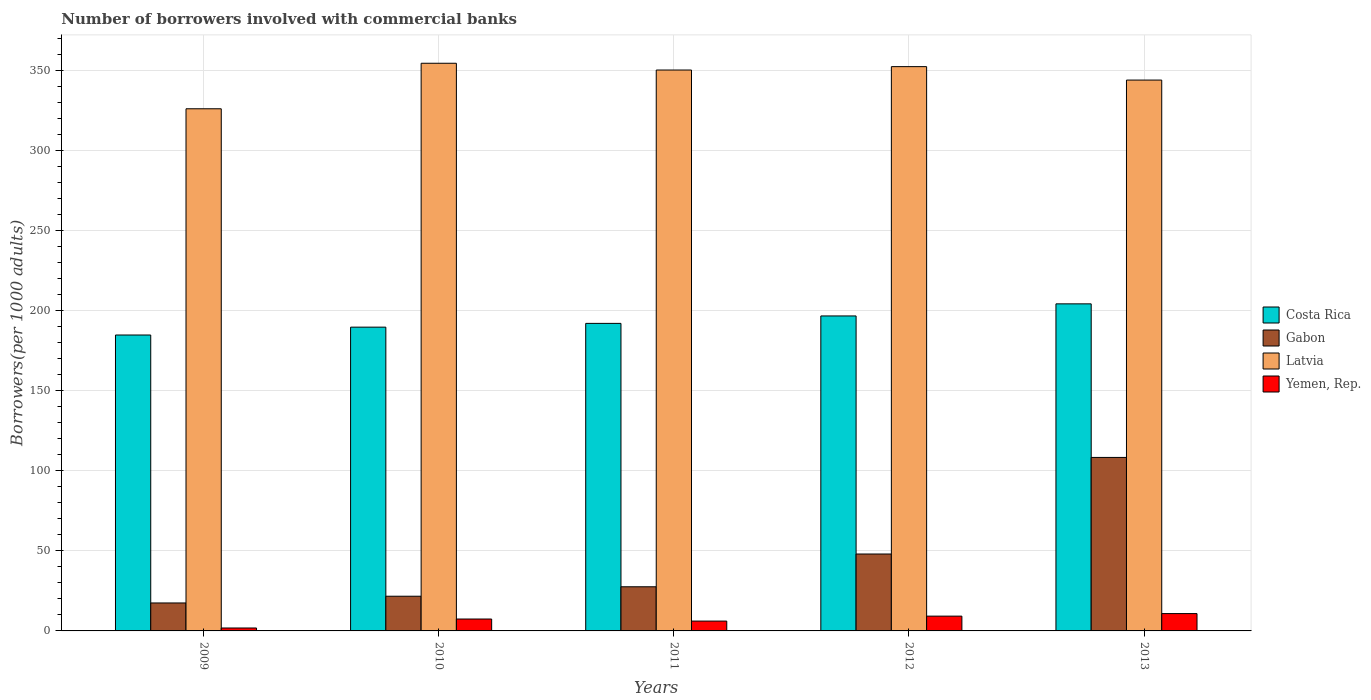How many different coloured bars are there?
Your answer should be very brief. 4. Are the number of bars per tick equal to the number of legend labels?
Your answer should be very brief. Yes. Are the number of bars on each tick of the X-axis equal?
Keep it short and to the point. Yes. How many bars are there on the 3rd tick from the left?
Offer a very short reply. 4. How many bars are there on the 2nd tick from the right?
Provide a short and direct response. 4. In how many cases, is the number of bars for a given year not equal to the number of legend labels?
Provide a succinct answer. 0. What is the number of borrowers involved with commercial banks in Yemen, Rep. in 2012?
Your response must be concise. 9.23. Across all years, what is the maximum number of borrowers involved with commercial banks in Gabon?
Offer a terse response. 108.3. Across all years, what is the minimum number of borrowers involved with commercial banks in Yemen, Rep.?
Your answer should be compact. 1.83. What is the total number of borrowers involved with commercial banks in Gabon in the graph?
Give a very brief answer. 222.99. What is the difference between the number of borrowers involved with commercial banks in Costa Rica in 2009 and that in 2012?
Your answer should be very brief. -11.9. What is the difference between the number of borrowers involved with commercial banks in Costa Rica in 2010 and the number of borrowers involved with commercial banks in Yemen, Rep. in 2009?
Make the answer very short. 187.8. What is the average number of borrowers involved with commercial banks in Gabon per year?
Offer a very short reply. 44.6. In the year 2010, what is the difference between the number of borrowers involved with commercial banks in Yemen, Rep. and number of borrowers involved with commercial banks in Gabon?
Keep it short and to the point. -14.22. In how many years, is the number of borrowers involved with commercial banks in Latvia greater than 90?
Offer a terse response. 5. What is the ratio of the number of borrowers involved with commercial banks in Gabon in 2010 to that in 2011?
Ensure brevity in your answer.  0.79. Is the number of borrowers involved with commercial banks in Yemen, Rep. in 2011 less than that in 2013?
Your response must be concise. Yes. Is the difference between the number of borrowers involved with commercial banks in Yemen, Rep. in 2011 and 2012 greater than the difference between the number of borrowers involved with commercial banks in Gabon in 2011 and 2012?
Your answer should be very brief. Yes. What is the difference between the highest and the second highest number of borrowers involved with commercial banks in Yemen, Rep.?
Ensure brevity in your answer.  1.58. What is the difference between the highest and the lowest number of borrowers involved with commercial banks in Yemen, Rep.?
Keep it short and to the point. 8.99. In how many years, is the number of borrowers involved with commercial banks in Yemen, Rep. greater than the average number of borrowers involved with commercial banks in Yemen, Rep. taken over all years?
Provide a short and direct response. 3. What does the 3rd bar from the left in 2012 represents?
Your response must be concise. Latvia. Is it the case that in every year, the sum of the number of borrowers involved with commercial banks in Latvia and number of borrowers involved with commercial banks in Yemen, Rep. is greater than the number of borrowers involved with commercial banks in Gabon?
Offer a very short reply. Yes. How many bars are there?
Provide a succinct answer. 20. What is the difference between two consecutive major ticks on the Y-axis?
Provide a succinct answer. 50. Are the values on the major ticks of Y-axis written in scientific E-notation?
Offer a terse response. No. How many legend labels are there?
Your answer should be very brief. 4. How are the legend labels stacked?
Keep it short and to the point. Vertical. What is the title of the graph?
Provide a short and direct response. Number of borrowers involved with commercial banks. Does "Equatorial Guinea" appear as one of the legend labels in the graph?
Your answer should be very brief. No. What is the label or title of the Y-axis?
Keep it short and to the point. Borrowers(per 1000 adults). What is the Borrowers(per 1000 adults) in Costa Rica in 2009?
Keep it short and to the point. 184.73. What is the Borrowers(per 1000 adults) in Gabon in 2009?
Offer a terse response. 17.46. What is the Borrowers(per 1000 adults) in Latvia in 2009?
Give a very brief answer. 325.95. What is the Borrowers(per 1000 adults) of Yemen, Rep. in 2009?
Provide a short and direct response. 1.83. What is the Borrowers(per 1000 adults) of Costa Rica in 2010?
Keep it short and to the point. 189.63. What is the Borrowers(per 1000 adults) of Gabon in 2010?
Make the answer very short. 21.66. What is the Borrowers(per 1000 adults) of Latvia in 2010?
Ensure brevity in your answer.  354.36. What is the Borrowers(per 1000 adults) of Yemen, Rep. in 2010?
Offer a terse response. 7.43. What is the Borrowers(per 1000 adults) in Costa Rica in 2011?
Your answer should be very brief. 191.98. What is the Borrowers(per 1000 adults) in Gabon in 2011?
Provide a short and direct response. 27.56. What is the Borrowers(per 1000 adults) of Latvia in 2011?
Offer a terse response. 350.14. What is the Borrowers(per 1000 adults) in Yemen, Rep. in 2011?
Your answer should be compact. 6.14. What is the Borrowers(per 1000 adults) of Costa Rica in 2012?
Give a very brief answer. 196.62. What is the Borrowers(per 1000 adults) of Gabon in 2012?
Your answer should be compact. 48.02. What is the Borrowers(per 1000 adults) in Latvia in 2012?
Provide a succinct answer. 352.26. What is the Borrowers(per 1000 adults) in Yemen, Rep. in 2012?
Provide a succinct answer. 9.23. What is the Borrowers(per 1000 adults) of Costa Rica in 2013?
Ensure brevity in your answer.  204.18. What is the Borrowers(per 1000 adults) in Gabon in 2013?
Your answer should be very brief. 108.3. What is the Borrowers(per 1000 adults) in Latvia in 2013?
Give a very brief answer. 343.87. What is the Borrowers(per 1000 adults) of Yemen, Rep. in 2013?
Provide a succinct answer. 10.82. Across all years, what is the maximum Borrowers(per 1000 adults) of Costa Rica?
Offer a terse response. 204.18. Across all years, what is the maximum Borrowers(per 1000 adults) in Gabon?
Your answer should be compact. 108.3. Across all years, what is the maximum Borrowers(per 1000 adults) of Latvia?
Your response must be concise. 354.36. Across all years, what is the maximum Borrowers(per 1000 adults) of Yemen, Rep.?
Provide a short and direct response. 10.82. Across all years, what is the minimum Borrowers(per 1000 adults) in Costa Rica?
Give a very brief answer. 184.73. Across all years, what is the minimum Borrowers(per 1000 adults) in Gabon?
Make the answer very short. 17.46. Across all years, what is the minimum Borrowers(per 1000 adults) in Latvia?
Keep it short and to the point. 325.95. Across all years, what is the minimum Borrowers(per 1000 adults) in Yemen, Rep.?
Provide a succinct answer. 1.83. What is the total Borrowers(per 1000 adults) in Costa Rica in the graph?
Offer a terse response. 967.14. What is the total Borrowers(per 1000 adults) in Gabon in the graph?
Offer a terse response. 222.99. What is the total Borrowers(per 1000 adults) of Latvia in the graph?
Your response must be concise. 1726.58. What is the total Borrowers(per 1000 adults) of Yemen, Rep. in the graph?
Offer a very short reply. 35.45. What is the difference between the Borrowers(per 1000 adults) in Costa Rica in 2009 and that in 2010?
Give a very brief answer. -4.9. What is the difference between the Borrowers(per 1000 adults) of Gabon in 2009 and that in 2010?
Your answer should be compact. -4.2. What is the difference between the Borrowers(per 1000 adults) of Latvia in 2009 and that in 2010?
Give a very brief answer. -28.41. What is the difference between the Borrowers(per 1000 adults) in Yemen, Rep. in 2009 and that in 2010?
Provide a succinct answer. -5.6. What is the difference between the Borrowers(per 1000 adults) of Costa Rica in 2009 and that in 2011?
Your answer should be very brief. -7.25. What is the difference between the Borrowers(per 1000 adults) of Gabon in 2009 and that in 2011?
Your response must be concise. -10.1. What is the difference between the Borrowers(per 1000 adults) of Latvia in 2009 and that in 2011?
Provide a short and direct response. -24.19. What is the difference between the Borrowers(per 1000 adults) of Yemen, Rep. in 2009 and that in 2011?
Your answer should be very brief. -4.32. What is the difference between the Borrowers(per 1000 adults) of Costa Rica in 2009 and that in 2012?
Ensure brevity in your answer.  -11.9. What is the difference between the Borrowers(per 1000 adults) of Gabon in 2009 and that in 2012?
Provide a short and direct response. -30.56. What is the difference between the Borrowers(per 1000 adults) of Latvia in 2009 and that in 2012?
Offer a terse response. -26.3. What is the difference between the Borrowers(per 1000 adults) of Yemen, Rep. in 2009 and that in 2012?
Give a very brief answer. -7.41. What is the difference between the Borrowers(per 1000 adults) of Costa Rica in 2009 and that in 2013?
Ensure brevity in your answer.  -19.45. What is the difference between the Borrowers(per 1000 adults) of Gabon in 2009 and that in 2013?
Keep it short and to the point. -90.84. What is the difference between the Borrowers(per 1000 adults) of Latvia in 2009 and that in 2013?
Your answer should be compact. -17.92. What is the difference between the Borrowers(per 1000 adults) in Yemen, Rep. in 2009 and that in 2013?
Make the answer very short. -8.99. What is the difference between the Borrowers(per 1000 adults) of Costa Rica in 2010 and that in 2011?
Make the answer very short. -2.35. What is the difference between the Borrowers(per 1000 adults) of Gabon in 2010 and that in 2011?
Make the answer very short. -5.9. What is the difference between the Borrowers(per 1000 adults) of Latvia in 2010 and that in 2011?
Provide a short and direct response. 4.22. What is the difference between the Borrowers(per 1000 adults) of Yemen, Rep. in 2010 and that in 2011?
Offer a terse response. 1.29. What is the difference between the Borrowers(per 1000 adults) of Costa Rica in 2010 and that in 2012?
Your answer should be very brief. -6.99. What is the difference between the Borrowers(per 1000 adults) in Gabon in 2010 and that in 2012?
Provide a short and direct response. -26.36. What is the difference between the Borrowers(per 1000 adults) in Latvia in 2010 and that in 2012?
Offer a terse response. 2.11. What is the difference between the Borrowers(per 1000 adults) of Yemen, Rep. in 2010 and that in 2012?
Your answer should be very brief. -1.8. What is the difference between the Borrowers(per 1000 adults) in Costa Rica in 2010 and that in 2013?
Your response must be concise. -14.55. What is the difference between the Borrowers(per 1000 adults) in Gabon in 2010 and that in 2013?
Ensure brevity in your answer.  -86.65. What is the difference between the Borrowers(per 1000 adults) of Latvia in 2010 and that in 2013?
Keep it short and to the point. 10.49. What is the difference between the Borrowers(per 1000 adults) in Yemen, Rep. in 2010 and that in 2013?
Give a very brief answer. -3.39. What is the difference between the Borrowers(per 1000 adults) in Costa Rica in 2011 and that in 2012?
Provide a succinct answer. -4.64. What is the difference between the Borrowers(per 1000 adults) in Gabon in 2011 and that in 2012?
Ensure brevity in your answer.  -20.46. What is the difference between the Borrowers(per 1000 adults) of Latvia in 2011 and that in 2012?
Ensure brevity in your answer.  -2.12. What is the difference between the Borrowers(per 1000 adults) of Yemen, Rep. in 2011 and that in 2012?
Provide a succinct answer. -3.09. What is the difference between the Borrowers(per 1000 adults) of Costa Rica in 2011 and that in 2013?
Your answer should be compact. -12.19. What is the difference between the Borrowers(per 1000 adults) of Gabon in 2011 and that in 2013?
Your answer should be very brief. -80.74. What is the difference between the Borrowers(per 1000 adults) of Latvia in 2011 and that in 2013?
Offer a terse response. 6.27. What is the difference between the Borrowers(per 1000 adults) in Yemen, Rep. in 2011 and that in 2013?
Provide a succinct answer. -4.67. What is the difference between the Borrowers(per 1000 adults) of Costa Rica in 2012 and that in 2013?
Ensure brevity in your answer.  -7.55. What is the difference between the Borrowers(per 1000 adults) of Gabon in 2012 and that in 2013?
Your response must be concise. -60.28. What is the difference between the Borrowers(per 1000 adults) of Latvia in 2012 and that in 2013?
Give a very brief answer. 8.39. What is the difference between the Borrowers(per 1000 adults) of Yemen, Rep. in 2012 and that in 2013?
Give a very brief answer. -1.58. What is the difference between the Borrowers(per 1000 adults) in Costa Rica in 2009 and the Borrowers(per 1000 adults) in Gabon in 2010?
Offer a very short reply. 163.07. What is the difference between the Borrowers(per 1000 adults) in Costa Rica in 2009 and the Borrowers(per 1000 adults) in Latvia in 2010?
Ensure brevity in your answer.  -169.63. What is the difference between the Borrowers(per 1000 adults) of Costa Rica in 2009 and the Borrowers(per 1000 adults) of Yemen, Rep. in 2010?
Provide a succinct answer. 177.3. What is the difference between the Borrowers(per 1000 adults) of Gabon in 2009 and the Borrowers(per 1000 adults) of Latvia in 2010?
Your response must be concise. -336.91. What is the difference between the Borrowers(per 1000 adults) of Gabon in 2009 and the Borrowers(per 1000 adults) of Yemen, Rep. in 2010?
Your answer should be compact. 10.03. What is the difference between the Borrowers(per 1000 adults) of Latvia in 2009 and the Borrowers(per 1000 adults) of Yemen, Rep. in 2010?
Your response must be concise. 318.52. What is the difference between the Borrowers(per 1000 adults) of Costa Rica in 2009 and the Borrowers(per 1000 adults) of Gabon in 2011?
Provide a succinct answer. 157.17. What is the difference between the Borrowers(per 1000 adults) in Costa Rica in 2009 and the Borrowers(per 1000 adults) in Latvia in 2011?
Your answer should be compact. -165.41. What is the difference between the Borrowers(per 1000 adults) in Costa Rica in 2009 and the Borrowers(per 1000 adults) in Yemen, Rep. in 2011?
Provide a short and direct response. 178.58. What is the difference between the Borrowers(per 1000 adults) of Gabon in 2009 and the Borrowers(per 1000 adults) of Latvia in 2011?
Offer a very short reply. -332.68. What is the difference between the Borrowers(per 1000 adults) of Gabon in 2009 and the Borrowers(per 1000 adults) of Yemen, Rep. in 2011?
Give a very brief answer. 11.31. What is the difference between the Borrowers(per 1000 adults) in Latvia in 2009 and the Borrowers(per 1000 adults) in Yemen, Rep. in 2011?
Give a very brief answer. 319.81. What is the difference between the Borrowers(per 1000 adults) in Costa Rica in 2009 and the Borrowers(per 1000 adults) in Gabon in 2012?
Provide a succinct answer. 136.71. What is the difference between the Borrowers(per 1000 adults) in Costa Rica in 2009 and the Borrowers(per 1000 adults) in Latvia in 2012?
Your answer should be very brief. -167.53. What is the difference between the Borrowers(per 1000 adults) of Costa Rica in 2009 and the Borrowers(per 1000 adults) of Yemen, Rep. in 2012?
Make the answer very short. 175.5. What is the difference between the Borrowers(per 1000 adults) in Gabon in 2009 and the Borrowers(per 1000 adults) in Latvia in 2012?
Your response must be concise. -334.8. What is the difference between the Borrowers(per 1000 adults) of Gabon in 2009 and the Borrowers(per 1000 adults) of Yemen, Rep. in 2012?
Offer a very short reply. 8.22. What is the difference between the Borrowers(per 1000 adults) in Latvia in 2009 and the Borrowers(per 1000 adults) in Yemen, Rep. in 2012?
Provide a short and direct response. 316.72. What is the difference between the Borrowers(per 1000 adults) of Costa Rica in 2009 and the Borrowers(per 1000 adults) of Gabon in 2013?
Your answer should be compact. 76.43. What is the difference between the Borrowers(per 1000 adults) of Costa Rica in 2009 and the Borrowers(per 1000 adults) of Latvia in 2013?
Provide a succinct answer. -159.14. What is the difference between the Borrowers(per 1000 adults) of Costa Rica in 2009 and the Borrowers(per 1000 adults) of Yemen, Rep. in 2013?
Make the answer very short. 173.91. What is the difference between the Borrowers(per 1000 adults) in Gabon in 2009 and the Borrowers(per 1000 adults) in Latvia in 2013?
Provide a short and direct response. -326.41. What is the difference between the Borrowers(per 1000 adults) of Gabon in 2009 and the Borrowers(per 1000 adults) of Yemen, Rep. in 2013?
Give a very brief answer. 6.64. What is the difference between the Borrowers(per 1000 adults) of Latvia in 2009 and the Borrowers(per 1000 adults) of Yemen, Rep. in 2013?
Offer a terse response. 315.13. What is the difference between the Borrowers(per 1000 adults) of Costa Rica in 2010 and the Borrowers(per 1000 adults) of Gabon in 2011?
Offer a terse response. 162.07. What is the difference between the Borrowers(per 1000 adults) in Costa Rica in 2010 and the Borrowers(per 1000 adults) in Latvia in 2011?
Your response must be concise. -160.51. What is the difference between the Borrowers(per 1000 adults) of Costa Rica in 2010 and the Borrowers(per 1000 adults) of Yemen, Rep. in 2011?
Provide a short and direct response. 183.49. What is the difference between the Borrowers(per 1000 adults) in Gabon in 2010 and the Borrowers(per 1000 adults) in Latvia in 2011?
Offer a very short reply. -328.48. What is the difference between the Borrowers(per 1000 adults) of Gabon in 2010 and the Borrowers(per 1000 adults) of Yemen, Rep. in 2011?
Make the answer very short. 15.51. What is the difference between the Borrowers(per 1000 adults) in Latvia in 2010 and the Borrowers(per 1000 adults) in Yemen, Rep. in 2011?
Keep it short and to the point. 348.22. What is the difference between the Borrowers(per 1000 adults) in Costa Rica in 2010 and the Borrowers(per 1000 adults) in Gabon in 2012?
Give a very brief answer. 141.61. What is the difference between the Borrowers(per 1000 adults) of Costa Rica in 2010 and the Borrowers(per 1000 adults) of Latvia in 2012?
Keep it short and to the point. -162.63. What is the difference between the Borrowers(per 1000 adults) in Costa Rica in 2010 and the Borrowers(per 1000 adults) in Yemen, Rep. in 2012?
Give a very brief answer. 180.4. What is the difference between the Borrowers(per 1000 adults) of Gabon in 2010 and the Borrowers(per 1000 adults) of Latvia in 2012?
Your answer should be compact. -330.6. What is the difference between the Borrowers(per 1000 adults) of Gabon in 2010 and the Borrowers(per 1000 adults) of Yemen, Rep. in 2012?
Provide a succinct answer. 12.42. What is the difference between the Borrowers(per 1000 adults) in Latvia in 2010 and the Borrowers(per 1000 adults) in Yemen, Rep. in 2012?
Give a very brief answer. 345.13. What is the difference between the Borrowers(per 1000 adults) in Costa Rica in 2010 and the Borrowers(per 1000 adults) in Gabon in 2013?
Your answer should be very brief. 81.33. What is the difference between the Borrowers(per 1000 adults) in Costa Rica in 2010 and the Borrowers(per 1000 adults) in Latvia in 2013?
Offer a terse response. -154.24. What is the difference between the Borrowers(per 1000 adults) of Costa Rica in 2010 and the Borrowers(per 1000 adults) of Yemen, Rep. in 2013?
Your answer should be compact. 178.81. What is the difference between the Borrowers(per 1000 adults) in Gabon in 2010 and the Borrowers(per 1000 adults) in Latvia in 2013?
Provide a short and direct response. -322.21. What is the difference between the Borrowers(per 1000 adults) of Gabon in 2010 and the Borrowers(per 1000 adults) of Yemen, Rep. in 2013?
Your answer should be compact. 10.84. What is the difference between the Borrowers(per 1000 adults) in Latvia in 2010 and the Borrowers(per 1000 adults) in Yemen, Rep. in 2013?
Offer a terse response. 343.55. What is the difference between the Borrowers(per 1000 adults) of Costa Rica in 2011 and the Borrowers(per 1000 adults) of Gabon in 2012?
Offer a terse response. 143.97. What is the difference between the Borrowers(per 1000 adults) in Costa Rica in 2011 and the Borrowers(per 1000 adults) in Latvia in 2012?
Offer a very short reply. -160.27. What is the difference between the Borrowers(per 1000 adults) of Costa Rica in 2011 and the Borrowers(per 1000 adults) of Yemen, Rep. in 2012?
Provide a succinct answer. 182.75. What is the difference between the Borrowers(per 1000 adults) in Gabon in 2011 and the Borrowers(per 1000 adults) in Latvia in 2012?
Your response must be concise. -324.7. What is the difference between the Borrowers(per 1000 adults) in Gabon in 2011 and the Borrowers(per 1000 adults) in Yemen, Rep. in 2012?
Provide a succinct answer. 18.33. What is the difference between the Borrowers(per 1000 adults) of Latvia in 2011 and the Borrowers(per 1000 adults) of Yemen, Rep. in 2012?
Your answer should be compact. 340.91. What is the difference between the Borrowers(per 1000 adults) in Costa Rica in 2011 and the Borrowers(per 1000 adults) in Gabon in 2013?
Your response must be concise. 83.68. What is the difference between the Borrowers(per 1000 adults) in Costa Rica in 2011 and the Borrowers(per 1000 adults) in Latvia in 2013?
Ensure brevity in your answer.  -151.89. What is the difference between the Borrowers(per 1000 adults) of Costa Rica in 2011 and the Borrowers(per 1000 adults) of Yemen, Rep. in 2013?
Give a very brief answer. 181.17. What is the difference between the Borrowers(per 1000 adults) of Gabon in 2011 and the Borrowers(per 1000 adults) of Latvia in 2013?
Offer a terse response. -316.31. What is the difference between the Borrowers(per 1000 adults) of Gabon in 2011 and the Borrowers(per 1000 adults) of Yemen, Rep. in 2013?
Provide a succinct answer. 16.74. What is the difference between the Borrowers(per 1000 adults) of Latvia in 2011 and the Borrowers(per 1000 adults) of Yemen, Rep. in 2013?
Your response must be concise. 339.32. What is the difference between the Borrowers(per 1000 adults) in Costa Rica in 2012 and the Borrowers(per 1000 adults) in Gabon in 2013?
Make the answer very short. 88.32. What is the difference between the Borrowers(per 1000 adults) of Costa Rica in 2012 and the Borrowers(per 1000 adults) of Latvia in 2013?
Provide a succinct answer. -147.24. What is the difference between the Borrowers(per 1000 adults) in Costa Rica in 2012 and the Borrowers(per 1000 adults) in Yemen, Rep. in 2013?
Your response must be concise. 185.81. What is the difference between the Borrowers(per 1000 adults) in Gabon in 2012 and the Borrowers(per 1000 adults) in Latvia in 2013?
Ensure brevity in your answer.  -295.85. What is the difference between the Borrowers(per 1000 adults) of Gabon in 2012 and the Borrowers(per 1000 adults) of Yemen, Rep. in 2013?
Provide a succinct answer. 37.2. What is the difference between the Borrowers(per 1000 adults) in Latvia in 2012 and the Borrowers(per 1000 adults) in Yemen, Rep. in 2013?
Offer a very short reply. 341.44. What is the average Borrowers(per 1000 adults) in Costa Rica per year?
Offer a terse response. 193.43. What is the average Borrowers(per 1000 adults) of Gabon per year?
Keep it short and to the point. 44.6. What is the average Borrowers(per 1000 adults) of Latvia per year?
Your answer should be compact. 345.32. What is the average Borrowers(per 1000 adults) of Yemen, Rep. per year?
Provide a succinct answer. 7.09. In the year 2009, what is the difference between the Borrowers(per 1000 adults) in Costa Rica and Borrowers(per 1000 adults) in Gabon?
Ensure brevity in your answer.  167.27. In the year 2009, what is the difference between the Borrowers(per 1000 adults) in Costa Rica and Borrowers(per 1000 adults) in Latvia?
Make the answer very short. -141.22. In the year 2009, what is the difference between the Borrowers(per 1000 adults) in Costa Rica and Borrowers(per 1000 adults) in Yemen, Rep.?
Ensure brevity in your answer.  182.9. In the year 2009, what is the difference between the Borrowers(per 1000 adults) of Gabon and Borrowers(per 1000 adults) of Latvia?
Ensure brevity in your answer.  -308.49. In the year 2009, what is the difference between the Borrowers(per 1000 adults) of Gabon and Borrowers(per 1000 adults) of Yemen, Rep.?
Your answer should be compact. 15.63. In the year 2009, what is the difference between the Borrowers(per 1000 adults) in Latvia and Borrowers(per 1000 adults) in Yemen, Rep.?
Offer a very short reply. 324.12. In the year 2010, what is the difference between the Borrowers(per 1000 adults) in Costa Rica and Borrowers(per 1000 adults) in Gabon?
Ensure brevity in your answer.  167.97. In the year 2010, what is the difference between the Borrowers(per 1000 adults) in Costa Rica and Borrowers(per 1000 adults) in Latvia?
Keep it short and to the point. -164.73. In the year 2010, what is the difference between the Borrowers(per 1000 adults) of Costa Rica and Borrowers(per 1000 adults) of Yemen, Rep.?
Your answer should be compact. 182.2. In the year 2010, what is the difference between the Borrowers(per 1000 adults) of Gabon and Borrowers(per 1000 adults) of Latvia?
Offer a terse response. -332.71. In the year 2010, what is the difference between the Borrowers(per 1000 adults) in Gabon and Borrowers(per 1000 adults) in Yemen, Rep.?
Ensure brevity in your answer.  14.22. In the year 2010, what is the difference between the Borrowers(per 1000 adults) of Latvia and Borrowers(per 1000 adults) of Yemen, Rep.?
Provide a short and direct response. 346.93. In the year 2011, what is the difference between the Borrowers(per 1000 adults) of Costa Rica and Borrowers(per 1000 adults) of Gabon?
Make the answer very short. 164.42. In the year 2011, what is the difference between the Borrowers(per 1000 adults) of Costa Rica and Borrowers(per 1000 adults) of Latvia?
Ensure brevity in your answer.  -158.16. In the year 2011, what is the difference between the Borrowers(per 1000 adults) of Costa Rica and Borrowers(per 1000 adults) of Yemen, Rep.?
Make the answer very short. 185.84. In the year 2011, what is the difference between the Borrowers(per 1000 adults) of Gabon and Borrowers(per 1000 adults) of Latvia?
Make the answer very short. -322.58. In the year 2011, what is the difference between the Borrowers(per 1000 adults) in Gabon and Borrowers(per 1000 adults) in Yemen, Rep.?
Make the answer very short. 21.42. In the year 2011, what is the difference between the Borrowers(per 1000 adults) in Latvia and Borrowers(per 1000 adults) in Yemen, Rep.?
Keep it short and to the point. 344. In the year 2012, what is the difference between the Borrowers(per 1000 adults) of Costa Rica and Borrowers(per 1000 adults) of Gabon?
Give a very brief answer. 148.61. In the year 2012, what is the difference between the Borrowers(per 1000 adults) in Costa Rica and Borrowers(per 1000 adults) in Latvia?
Offer a very short reply. -155.63. In the year 2012, what is the difference between the Borrowers(per 1000 adults) of Costa Rica and Borrowers(per 1000 adults) of Yemen, Rep.?
Provide a short and direct response. 187.39. In the year 2012, what is the difference between the Borrowers(per 1000 adults) of Gabon and Borrowers(per 1000 adults) of Latvia?
Your answer should be compact. -304.24. In the year 2012, what is the difference between the Borrowers(per 1000 adults) of Gabon and Borrowers(per 1000 adults) of Yemen, Rep.?
Your answer should be compact. 38.78. In the year 2012, what is the difference between the Borrowers(per 1000 adults) of Latvia and Borrowers(per 1000 adults) of Yemen, Rep.?
Ensure brevity in your answer.  343.02. In the year 2013, what is the difference between the Borrowers(per 1000 adults) in Costa Rica and Borrowers(per 1000 adults) in Gabon?
Keep it short and to the point. 95.87. In the year 2013, what is the difference between the Borrowers(per 1000 adults) of Costa Rica and Borrowers(per 1000 adults) of Latvia?
Your response must be concise. -139.69. In the year 2013, what is the difference between the Borrowers(per 1000 adults) of Costa Rica and Borrowers(per 1000 adults) of Yemen, Rep.?
Ensure brevity in your answer.  193.36. In the year 2013, what is the difference between the Borrowers(per 1000 adults) in Gabon and Borrowers(per 1000 adults) in Latvia?
Ensure brevity in your answer.  -235.57. In the year 2013, what is the difference between the Borrowers(per 1000 adults) of Gabon and Borrowers(per 1000 adults) of Yemen, Rep.?
Your answer should be compact. 97.48. In the year 2013, what is the difference between the Borrowers(per 1000 adults) of Latvia and Borrowers(per 1000 adults) of Yemen, Rep.?
Your response must be concise. 333.05. What is the ratio of the Borrowers(per 1000 adults) of Costa Rica in 2009 to that in 2010?
Keep it short and to the point. 0.97. What is the ratio of the Borrowers(per 1000 adults) in Gabon in 2009 to that in 2010?
Your response must be concise. 0.81. What is the ratio of the Borrowers(per 1000 adults) in Latvia in 2009 to that in 2010?
Ensure brevity in your answer.  0.92. What is the ratio of the Borrowers(per 1000 adults) of Yemen, Rep. in 2009 to that in 2010?
Offer a very short reply. 0.25. What is the ratio of the Borrowers(per 1000 adults) in Costa Rica in 2009 to that in 2011?
Offer a terse response. 0.96. What is the ratio of the Borrowers(per 1000 adults) in Gabon in 2009 to that in 2011?
Your answer should be very brief. 0.63. What is the ratio of the Borrowers(per 1000 adults) of Latvia in 2009 to that in 2011?
Offer a very short reply. 0.93. What is the ratio of the Borrowers(per 1000 adults) in Yemen, Rep. in 2009 to that in 2011?
Provide a short and direct response. 0.3. What is the ratio of the Borrowers(per 1000 adults) in Costa Rica in 2009 to that in 2012?
Ensure brevity in your answer.  0.94. What is the ratio of the Borrowers(per 1000 adults) in Gabon in 2009 to that in 2012?
Your response must be concise. 0.36. What is the ratio of the Borrowers(per 1000 adults) in Latvia in 2009 to that in 2012?
Ensure brevity in your answer.  0.93. What is the ratio of the Borrowers(per 1000 adults) in Yemen, Rep. in 2009 to that in 2012?
Give a very brief answer. 0.2. What is the ratio of the Borrowers(per 1000 adults) of Costa Rica in 2009 to that in 2013?
Your response must be concise. 0.9. What is the ratio of the Borrowers(per 1000 adults) in Gabon in 2009 to that in 2013?
Provide a short and direct response. 0.16. What is the ratio of the Borrowers(per 1000 adults) in Latvia in 2009 to that in 2013?
Provide a succinct answer. 0.95. What is the ratio of the Borrowers(per 1000 adults) in Yemen, Rep. in 2009 to that in 2013?
Offer a terse response. 0.17. What is the ratio of the Borrowers(per 1000 adults) in Gabon in 2010 to that in 2011?
Your response must be concise. 0.79. What is the ratio of the Borrowers(per 1000 adults) in Latvia in 2010 to that in 2011?
Offer a very short reply. 1.01. What is the ratio of the Borrowers(per 1000 adults) of Yemen, Rep. in 2010 to that in 2011?
Make the answer very short. 1.21. What is the ratio of the Borrowers(per 1000 adults) of Costa Rica in 2010 to that in 2012?
Make the answer very short. 0.96. What is the ratio of the Borrowers(per 1000 adults) in Gabon in 2010 to that in 2012?
Your response must be concise. 0.45. What is the ratio of the Borrowers(per 1000 adults) in Latvia in 2010 to that in 2012?
Keep it short and to the point. 1.01. What is the ratio of the Borrowers(per 1000 adults) in Yemen, Rep. in 2010 to that in 2012?
Make the answer very short. 0.8. What is the ratio of the Borrowers(per 1000 adults) of Costa Rica in 2010 to that in 2013?
Give a very brief answer. 0.93. What is the ratio of the Borrowers(per 1000 adults) in Gabon in 2010 to that in 2013?
Your response must be concise. 0.2. What is the ratio of the Borrowers(per 1000 adults) of Latvia in 2010 to that in 2013?
Offer a very short reply. 1.03. What is the ratio of the Borrowers(per 1000 adults) in Yemen, Rep. in 2010 to that in 2013?
Make the answer very short. 0.69. What is the ratio of the Borrowers(per 1000 adults) of Costa Rica in 2011 to that in 2012?
Give a very brief answer. 0.98. What is the ratio of the Borrowers(per 1000 adults) of Gabon in 2011 to that in 2012?
Your answer should be very brief. 0.57. What is the ratio of the Borrowers(per 1000 adults) in Latvia in 2011 to that in 2012?
Offer a very short reply. 0.99. What is the ratio of the Borrowers(per 1000 adults) in Yemen, Rep. in 2011 to that in 2012?
Give a very brief answer. 0.67. What is the ratio of the Borrowers(per 1000 adults) of Costa Rica in 2011 to that in 2013?
Ensure brevity in your answer.  0.94. What is the ratio of the Borrowers(per 1000 adults) in Gabon in 2011 to that in 2013?
Give a very brief answer. 0.25. What is the ratio of the Borrowers(per 1000 adults) in Latvia in 2011 to that in 2013?
Offer a terse response. 1.02. What is the ratio of the Borrowers(per 1000 adults) of Yemen, Rep. in 2011 to that in 2013?
Your answer should be compact. 0.57. What is the ratio of the Borrowers(per 1000 adults) of Costa Rica in 2012 to that in 2013?
Provide a succinct answer. 0.96. What is the ratio of the Borrowers(per 1000 adults) of Gabon in 2012 to that in 2013?
Make the answer very short. 0.44. What is the ratio of the Borrowers(per 1000 adults) in Latvia in 2012 to that in 2013?
Your answer should be very brief. 1.02. What is the ratio of the Borrowers(per 1000 adults) of Yemen, Rep. in 2012 to that in 2013?
Make the answer very short. 0.85. What is the difference between the highest and the second highest Borrowers(per 1000 adults) in Costa Rica?
Provide a short and direct response. 7.55. What is the difference between the highest and the second highest Borrowers(per 1000 adults) of Gabon?
Ensure brevity in your answer.  60.28. What is the difference between the highest and the second highest Borrowers(per 1000 adults) in Latvia?
Keep it short and to the point. 2.11. What is the difference between the highest and the second highest Borrowers(per 1000 adults) in Yemen, Rep.?
Keep it short and to the point. 1.58. What is the difference between the highest and the lowest Borrowers(per 1000 adults) of Costa Rica?
Provide a short and direct response. 19.45. What is the difference between the highest and the lowest Borrowers(per 1000 adults) in Gabon?
Give a very brief answer. 90.84. What is the difference between the highest and the lowest Borrowers(per 1000 adults) in Latvia?
Keep it short and to the point. 28.41. What is the difference between the highest and the lowest Borrowers(per 1000 adults) of Yemen, Rep.?
Your response must be concise. 8.99. 